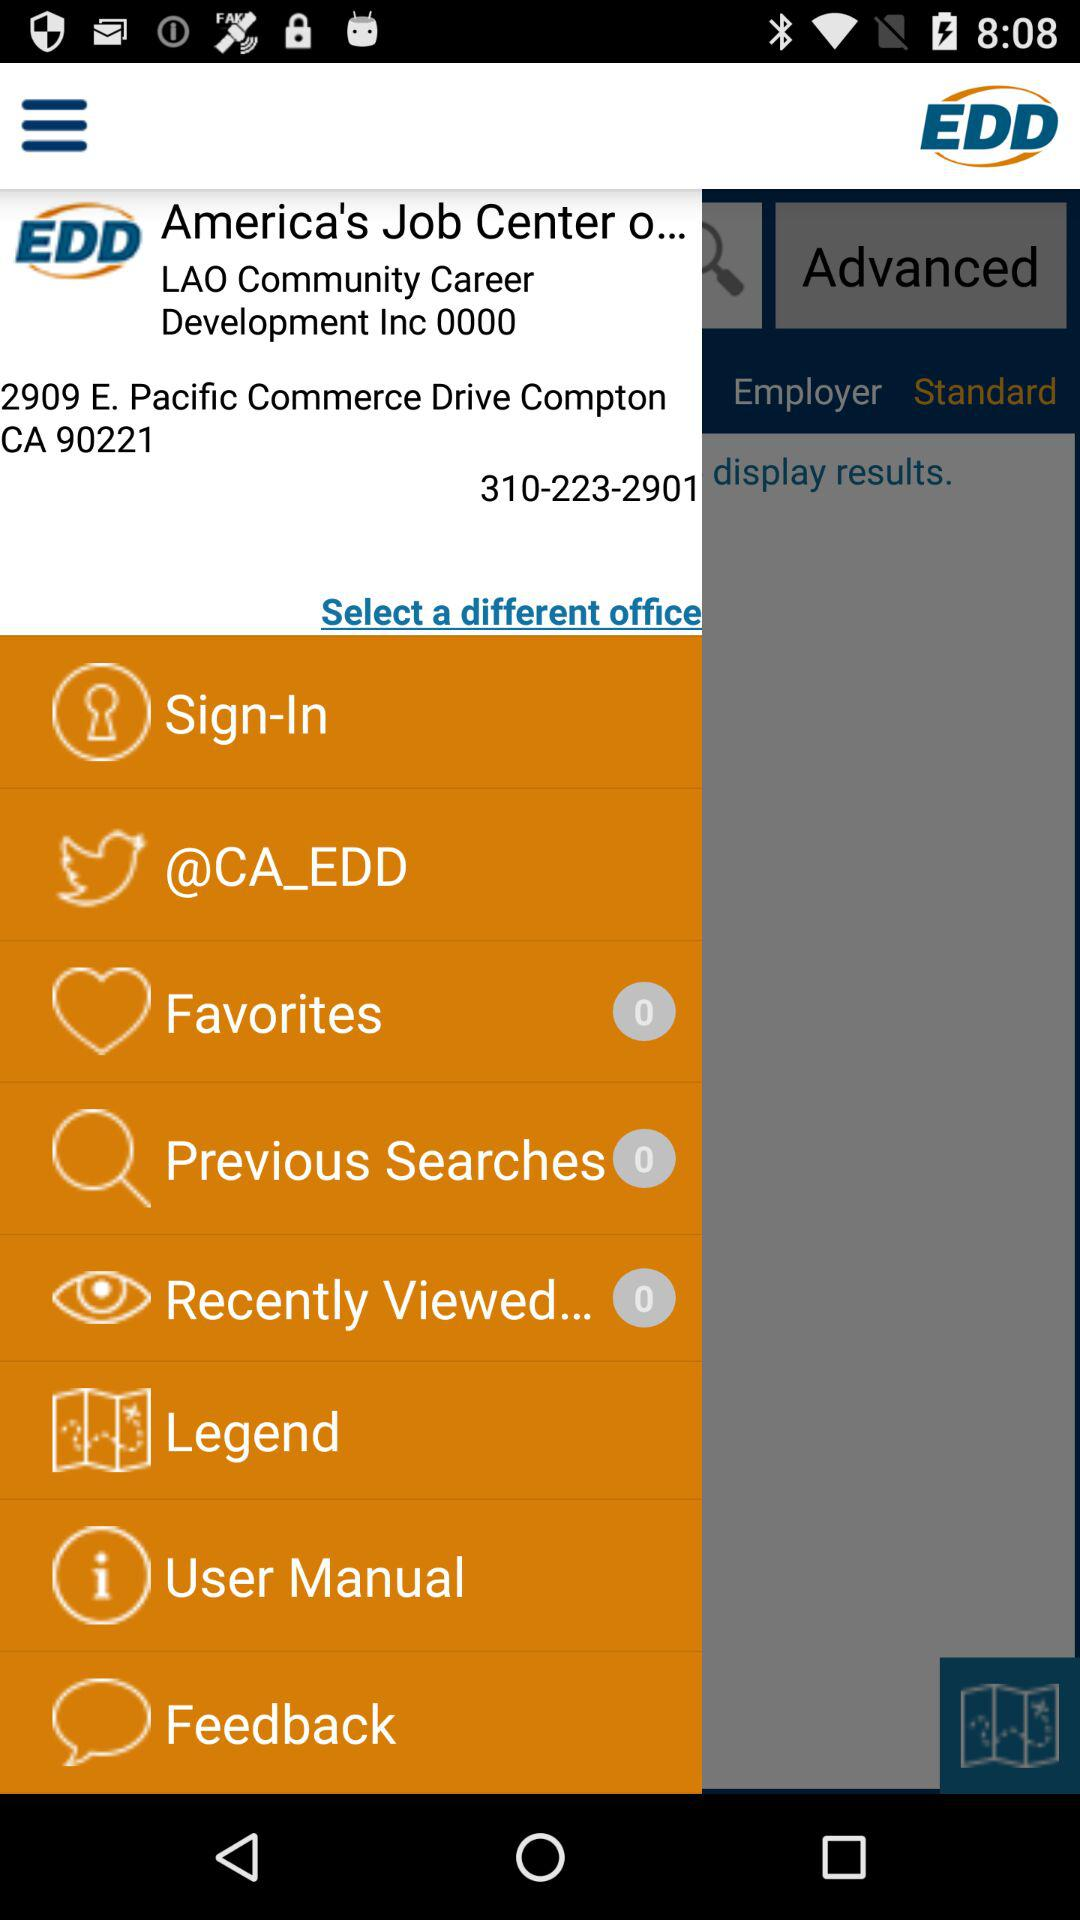How many previous searches are there? There are 0 previous searches. 